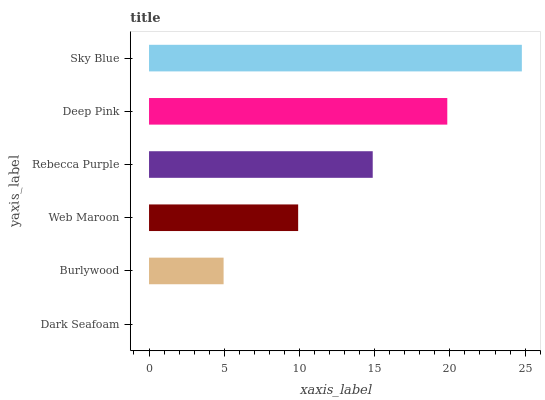Is Dark Seafoam the minimum?
Answer yes or no. Yes. Is Sky Blue the maximum?
Answer yes or no. Yes. Is Burlywood the minimum?
Answer yes or no. No. Is Burlywood the maximum?
Answer yes or no. No. Is Burlywood greater than Dark Seafoam?
Answer yes or no. Yes. Is Dark Seafoam less than Burlywood?
Answer yes or no. Yes. Is Dark Seafoam greater than Burlywood?
Answer yes or no. No. Is Burlywood less than Dark Seafoam?
Answer yes or no. No. Is Rebecca Purple the high median?
Answer yes or no. Yes. Is Web Maroon the low median?
Answer yes or no. Yes. Is Web Maroon the high median?
Answer yes or no. No. Is Deep Pink the low median?
Answer yes or no. No. 